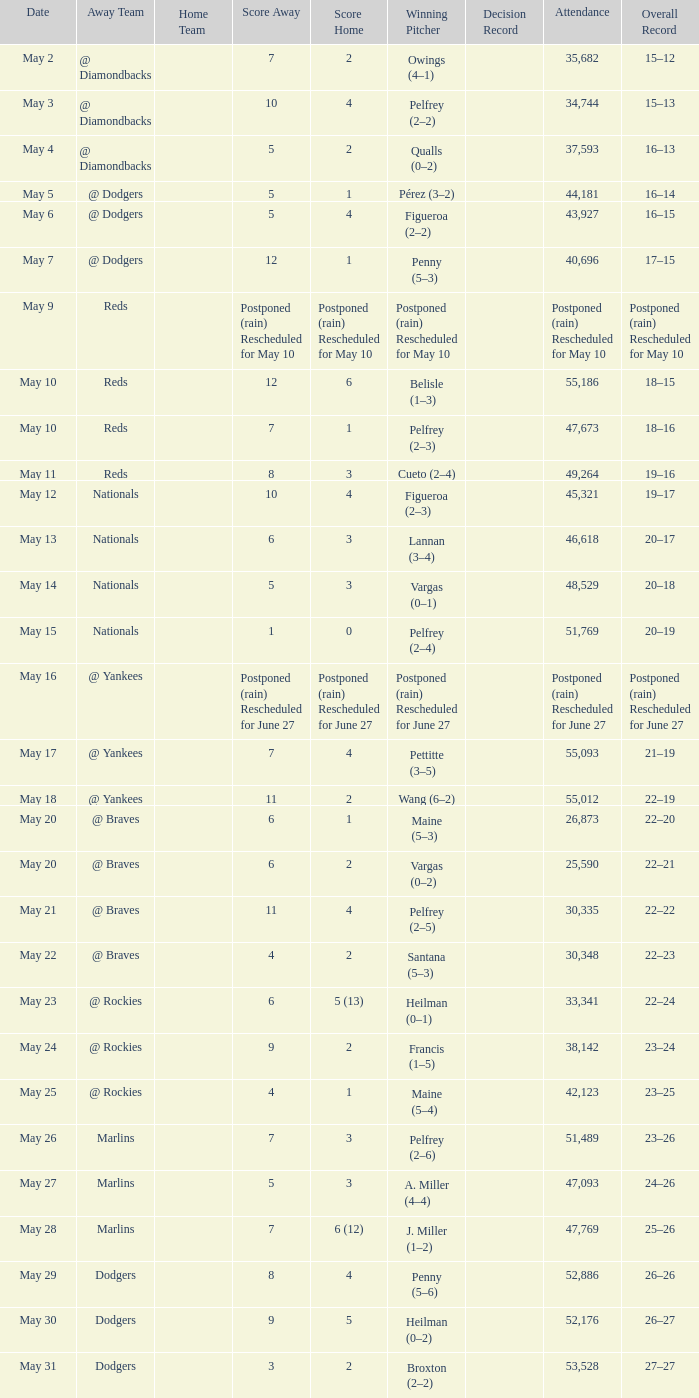Loss of postponed (rain) rescheduled for may 10 had what record? Postponed (rain) Rescheduled for May 10. 